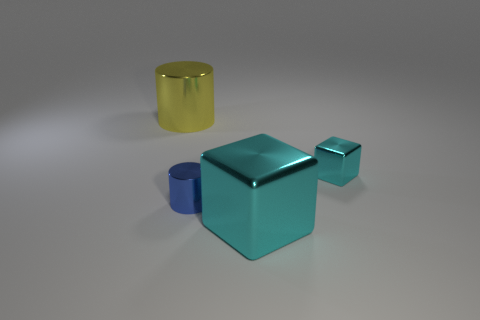Subtract 1 blocks. How many blocks are left? 1 Add 4 cyan blocks. How many objects exist? 8 Subtract all blue cylinders. How many cylinders are left? 1 Add 3 tiny cylinders. How many tiny cylinders exist? 4 Subtract 0 cyan cylinders. How many objects are left? 4 Subtract all purple blocks. Subtract all purple cylinders. How many blocks are left? 2 Subtract all large blue shiny balls. Subtract all big yellow objects. How many objects are left? 3 Add 2 large cylinders. How many large cylinders are left? 3 